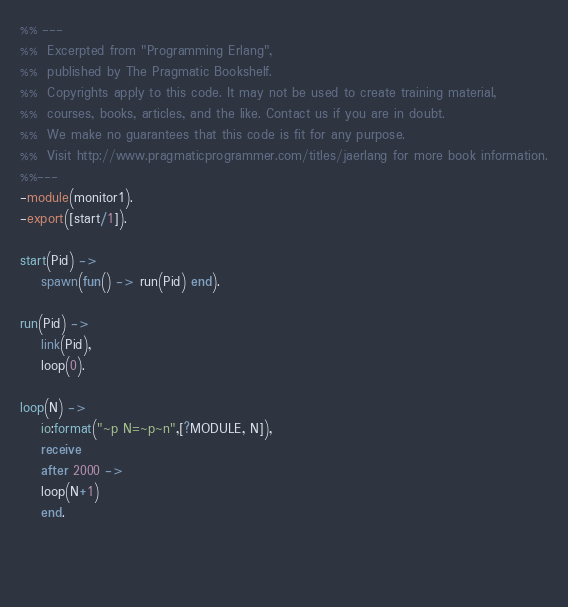<code> <loc_0><loc_0><loc_500><loc_500><_Erlang_>%% ---
%%  Excerpted from "Programming Erlang",
%%  published by The Pragmatic Bookshelf.
%%  Copyrights apply to this code. It may not be used to create training material, 
%%  courses, books, articles, and the like. Contact us if you are in doubt.
%%  We make no guarantees that this code is fit for any purpose. 
%%  Visit http://www.pragmaticprogrammer.com/titles/jaerlang for more book information.
%%---
-module(monitor1).
-export([start/1]).

start(Pid) ->
    spawn(fun() -> run(Pid) end).

run(Pid) ->
    link(Pid),
    loop(0).

loop(N) ->
    io:format("~p N=~p~n",[?MODULE, N]),
    receive
    after 2000 ->
	loop(N+1)
    end.
       
			 
			
</code> 